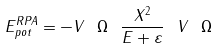<formula> <loc_0><loc_0><loc_500><loc_500>E _ { p o t } ^ { R P A } = - V \ \Omega \ \frac { X ^ { 2 } } { E + \varepsilon } \ V \ \Omega</formula> 